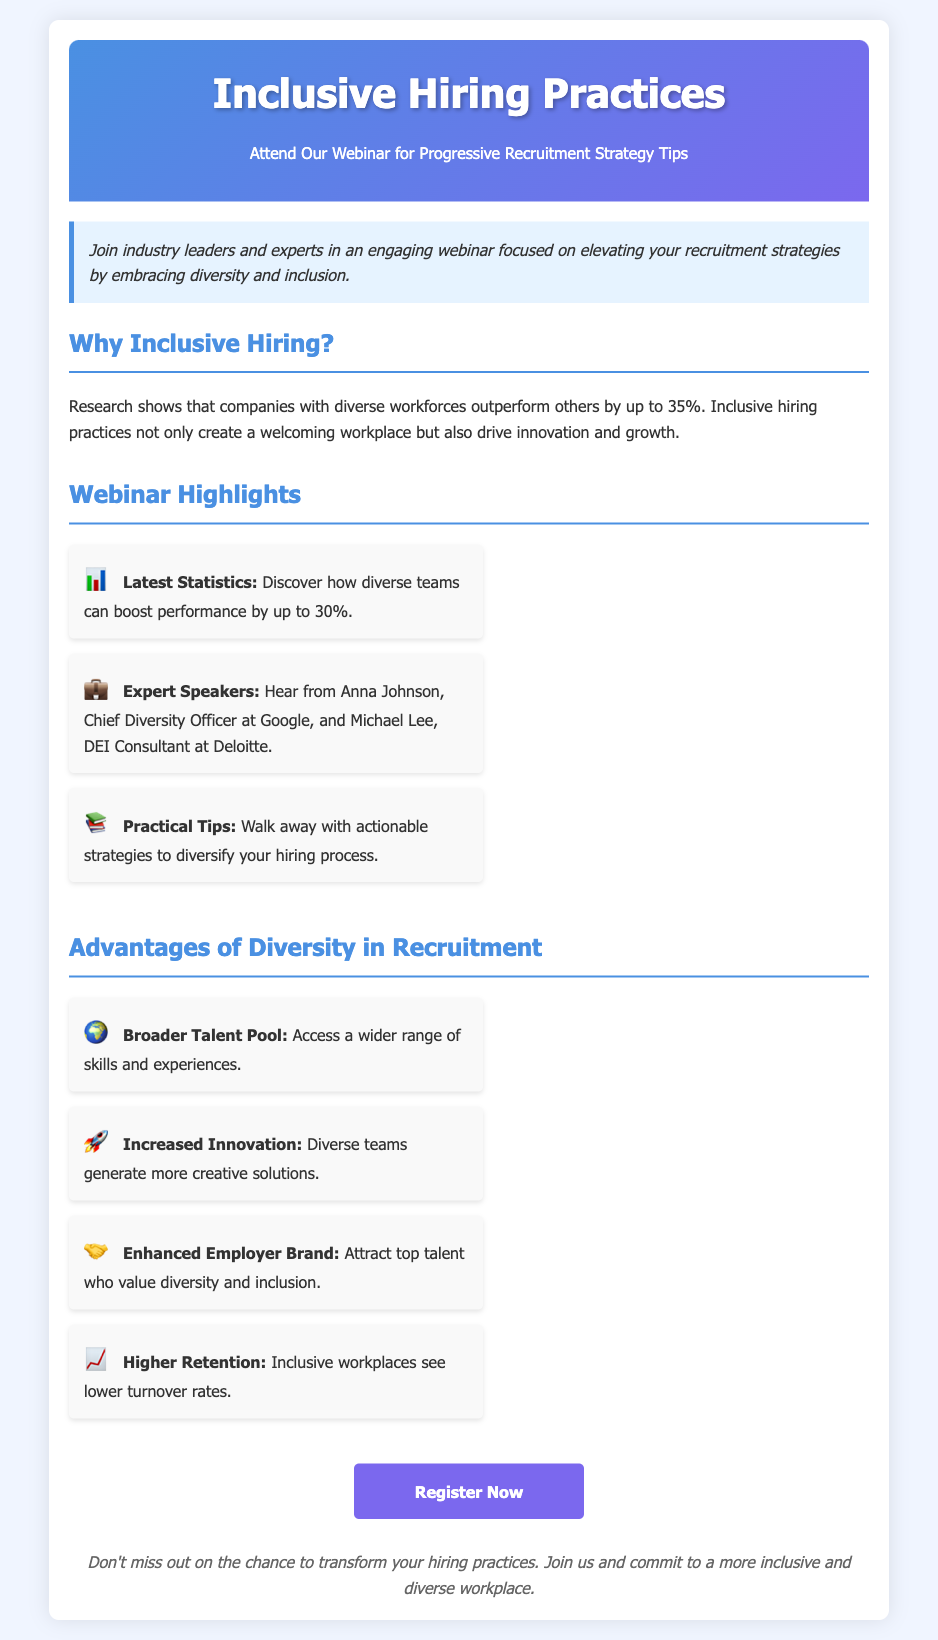what is the title of the webinar? The title of the webinar is highlighted in the header section, which is "Inclusive Hiring Practices."
Answer: Inclusive Hiring Practices who are the expert speakers mentioned? The expert speakers are listed in the webinar highlights section, which includes Anna Johnson and Michael Lee.
Answer: Anna Johnson, Michael Lee what is the percentage by which diverse workforces outperform others? The document states that diverse workforces outperform others by up to 35%.
Answer: up to 35% what is one practical takeaway from the webinar? One practical takeaway mentioned in the highlights is "actionable strategies to diversify your hiring process."
Answer: actionable strategies to diversify your hiring process what advantage does diversity bring in terms of innovation? The document states that diverse teams generate more creative solutions, highlighting the advantage of increased innovation.
Answer: Increased Innovation where can attendees register for the webinar? The call-to-action button provides a link for registration, which is found prominently as "Register Now."
Answer: http://example.com/webinar which icon represents the advantage of a broader talent pool? The icon next to the "Broader Talent Pool" advantage is depicted with a globe symbol.
Answer: 🌍 how does the document describe the impact of inclusive workplaces on turnover rates? The advantages section specifically states that inclusive workplaces see lower turnover rates.
Answer: lower turnover rates 